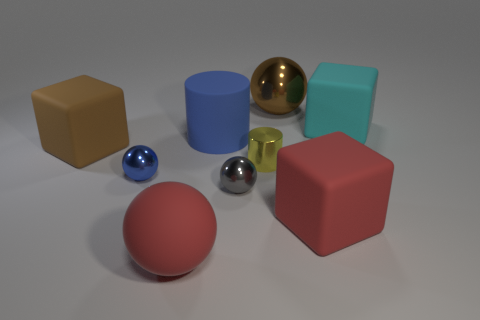There is a blue thing that is the same shape as the tiny yellow thing; what is it made of?
Keep it short and to the point. Rubber. What number of spheres are tiny things or brown rubber things?
Give a very brief answer. 2. What number of blocks have the same color as the big metallic object?
Keep it short and to the point. 1. What is the size of the thing that is in front of the large brown ball and behind the blue rubber cylinder?
Your answer should be very brief. Large. Is the number of big red balls behind the big cylinder less than the number of large balls?
Your answer should be compact. Yes. Does the big red ball have the same material as the yellow cylinder?
Offer a terse response. No. What number of things are either large shiny things or small yellow objects?
Keep it short and to the point. 2. What number of cylinders have the same material as the large brown sphere?
Provide a succinct answer. 1. What size is the cyan rubber object that is the same shape as the big brown matte object?
Give a very brief answer. Large. Are there any things to the right of the big brown metal thing?
Offer a terse response. Yes. 